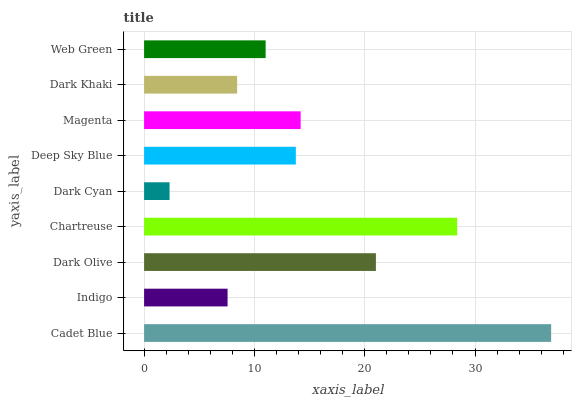Is Dark Cyan the minimum?
Answer yes or no. Yes. Is Cadet Blue the maximum?
Answer yes or no. Yes. Is Indigo the minimum?
Answer yes or no. No. Is Indigo the maximum?
Answer yes or no. No. Is Cadet Blue greater than Indigo?
Answer yes or no. Yes. Is Indigo less than Cadet Blue?
Answer yes or no. Yes. Is Indigo greater than Cadet Blue?
Answer yes or no. No. Is Cadet Blue less than Indigo?
Answer yes or no. No. Is Deep Sky Blue the high median?
Answer yes or no. Yes. Is Deep Sky Blue the low median?
Answer yes or no. Yes. Is Dark Cyan the high median?
Answer yes or no. No. Is Dark Cyan the low median?
Answer yes or no. No. 